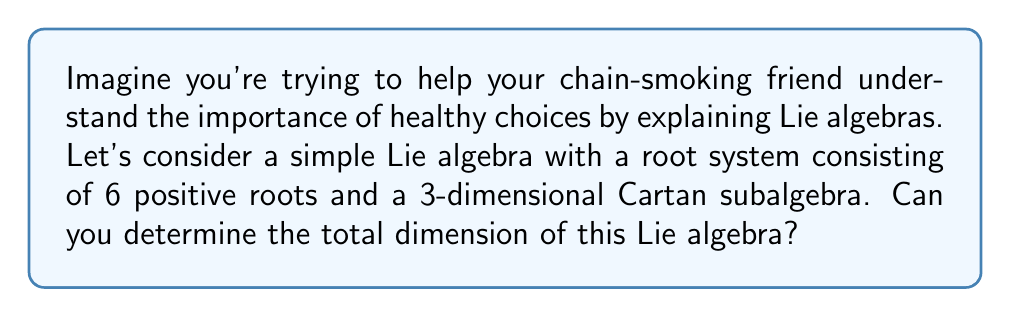Show me your answer to this math problem. Let's break this down step-by-step:

1) The dimension of a Lie algebra can be computed using the formula:

   $$\dim(L) = \dim(H) + 2|\Phi^+|$$

   where $L$ is the Lie algebra, $H$ is the Cartan subalgebra, and $\Phi^+$ is the set of positive roots.

2) We're given that:
   - The Cartan subalgebra is 3-dimensional, so $\dim(H) = 3$
   - There are 6 positive roots, so $|\Phi^+| = 6$

3) Let's substitute these values into our formula:

   $$\dim(L) = 3 + 2(6)$$

4) Simplify:
   $$\dim(L) = 3 + 12 = 15$$

Just like how understanding the structure of a Lie algebra can help us appreciate its complexity, understanding the structure of our bodies can help us appreciate the importance of making healthy choices.
Answer: The dimension of the Lie algebra is 15. 